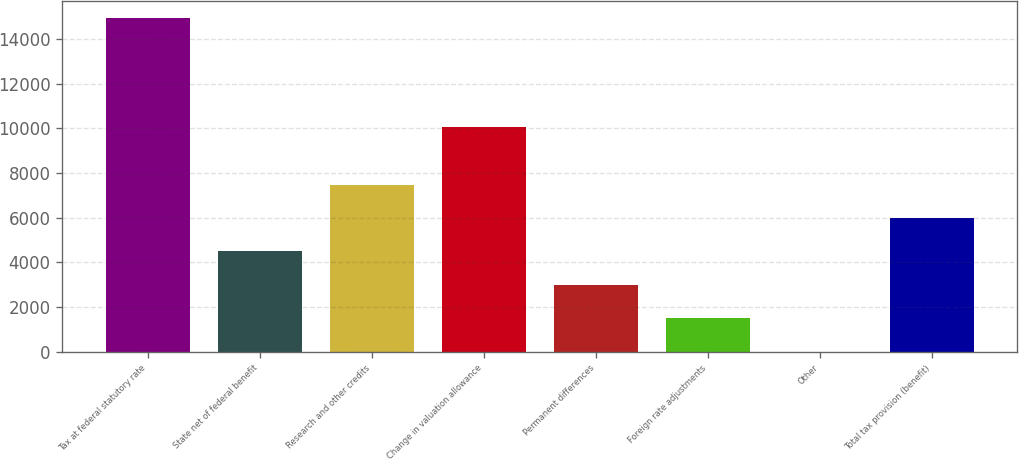<chart> <loc_0><loc_0><loc_500><loc_500><bar_chart><fcel>Tax at federal statutory rate<fcel>State net of federal benefit<fcel>Research and other credits<fcel>Change in valuation allowance<fcel>Permanent differences<fcel>Foreign rate adjustments<fcel>Other<fcel>Total tax provision (benefit)<nl><fcel>14945<fcel>4489.1<fcel>7476.5<fcel>10038<fcel>2995.4<fcel>1501.7<fcel>8<fcel>5982.8<nl></chart> 